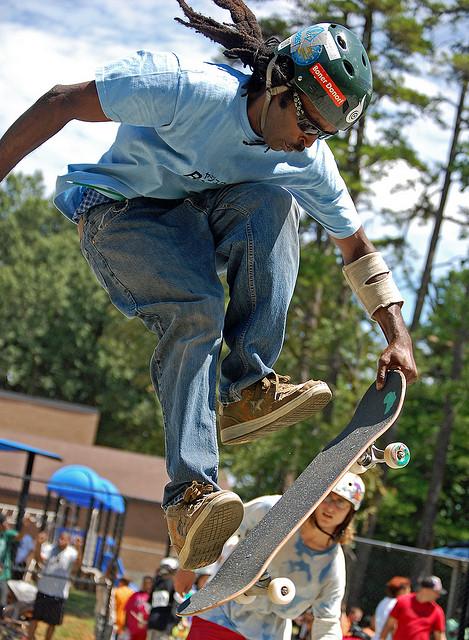Is the border jumping wearing a helmet?
Keep it brief. Yes. How much safety protection is he wearing?
Be succinct. 2. Who is on the kids hat?
Short answer required. No one. Is a man or a woman riding the skateboard?
Write a very short answer. Man. 